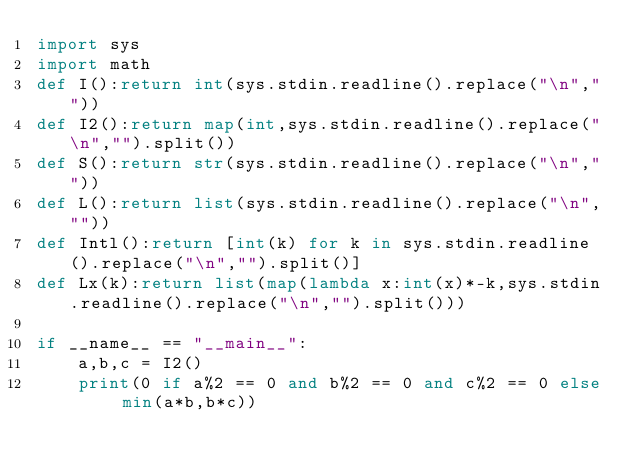<code> <loc_0><loc_0><loc_500><loc_500><_Python_>import sys
import math
def I():return int(sys.stdin.readline().replace("\n",""))
def I2():return map(int,sys.stdin.readline().replace("\n","").split())
def S():return str(sys.stdin.readline().replace("\n",""))
def L():return list(sys.stdin.readline().replace("\n",""))
def Intl():return [int(k) for k in sys.stdin.readline().replace("\n","").split()]
def Lx(k):return list(map(lambda x:int(x)*-k,sys.stdin.readline().replace("\n","").split()))

if __name__ == "__main__":
    a,b,c = I2()
    print(0 if a%2 == 0 and b%2 == 0 and c%2 == 0 else min(a*b,b*c))</code> 